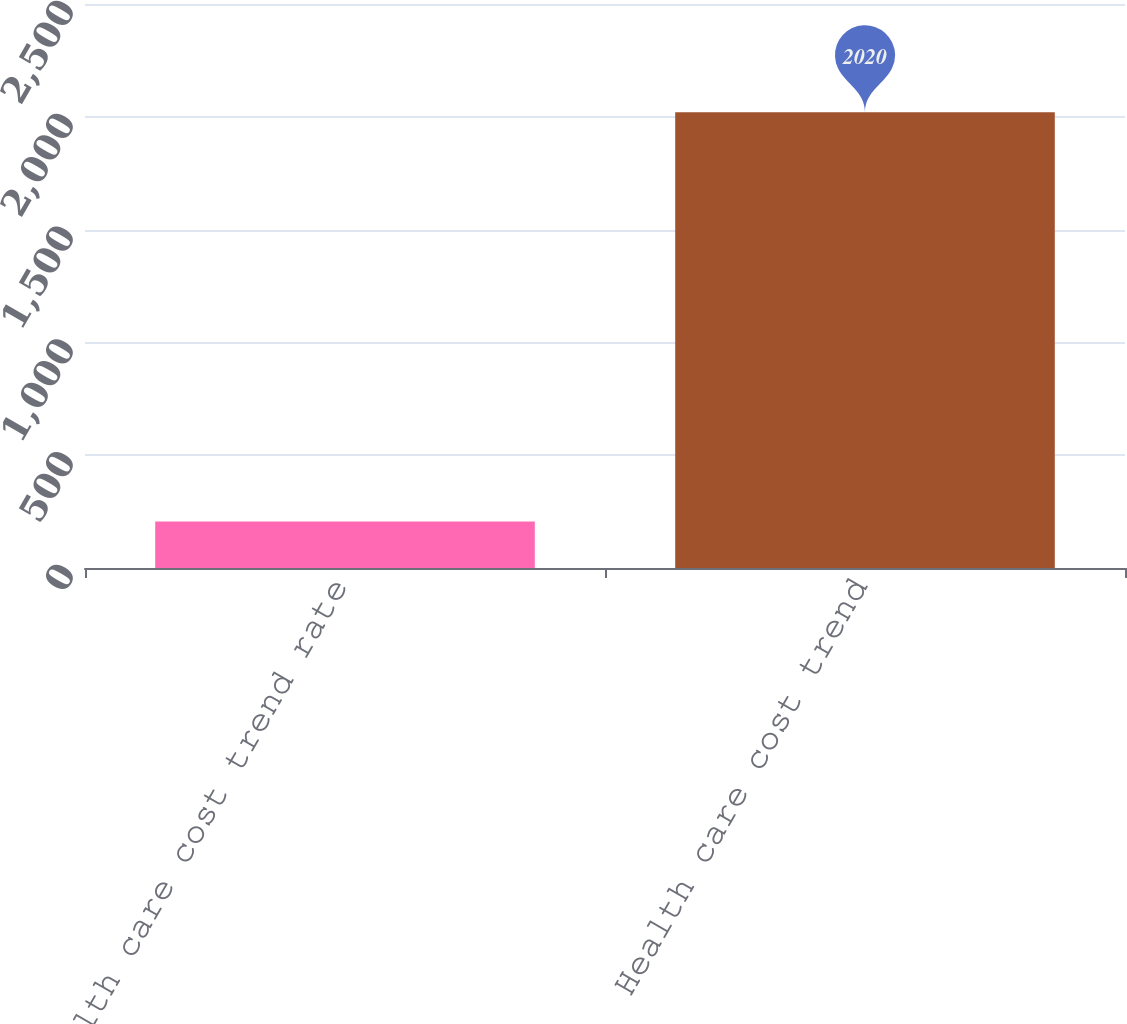Convert chart. <chart><loc_0><loc_0><loc_500><loc_500><bar_chart><fcel>Health care cost trend rate<fcel>Health care cost trend<nl><fcel>206.5<fcel>2020<nl></chart> 